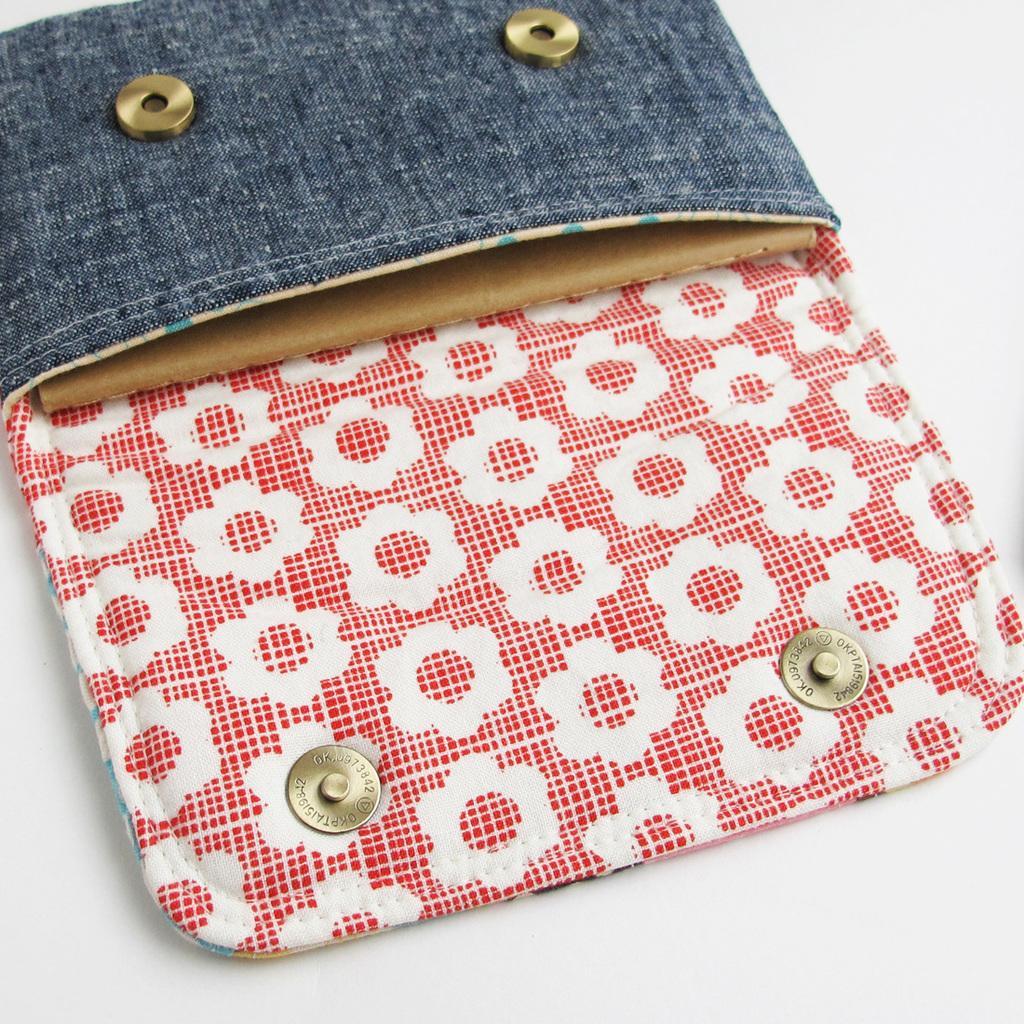Describe this image in one or two sentences. In this image we can see a wallet on a white color platform. 